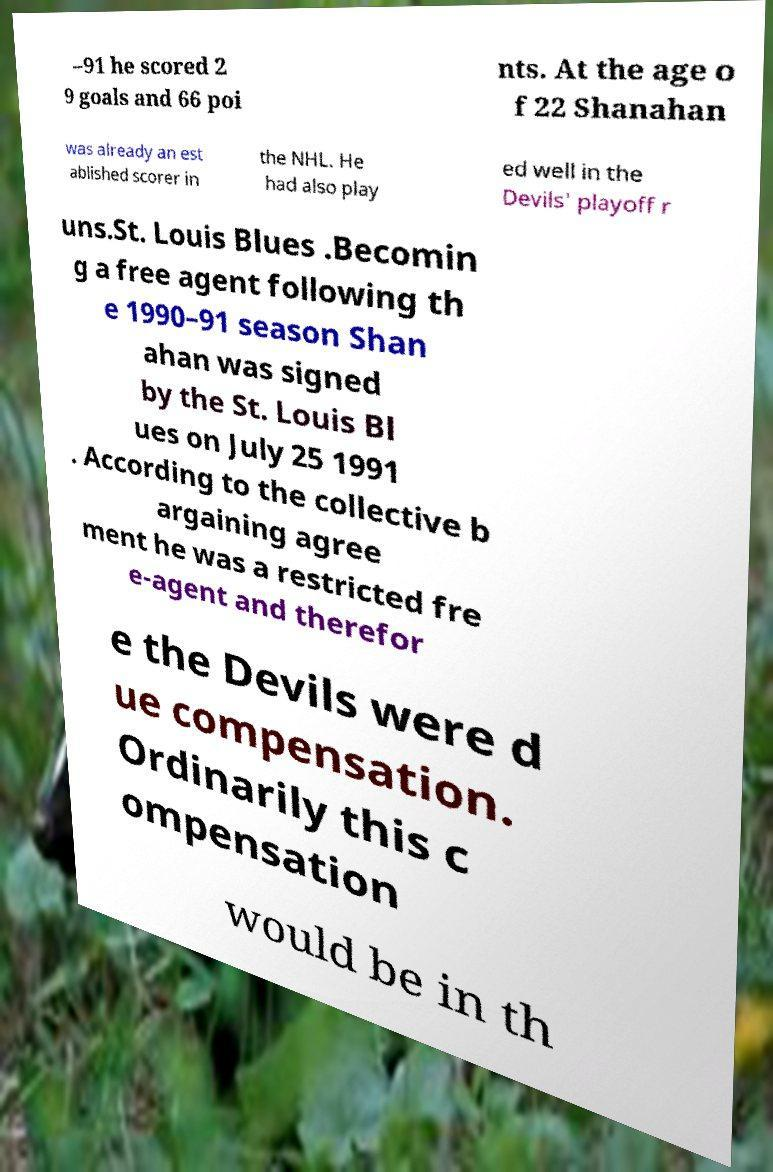Please identify and transcribe the text found in this image. –91 he scored 2 9 goals and 66 poi nts. At the age o f 22 Shanahan was already an est ablished scorer in the NHL. He had also play ed well in the Devils' playoff r uns.St. Louis Blues .Becomin g a free agent following th e 1990–91 season Shan ahan was signed by the St. Louis Bl ues on July 25 1991 . According to the collective b argaining agree ment he was a restricted fre e-agent and therefor e the Devils were d ue compensation. Ordinarily this c ompensation would be in th 